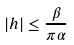<formula> <loc_0><loc_0><loc_500><loc_500>| h | \leq \frac { \beta } { \pi \alpha }</formula> 